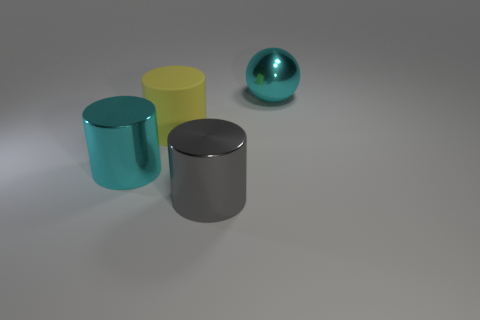Add 3 big gray objects. How many objects exist? 7 Subtract all cylinders. How many objects are left? 1 Subtract all big cubes. Subtract all large cylinders. How many objects are left? 1 Add 4 gray metallic things. How many gray metallic things are left? 5 Add 2 big rubber cylinders. How many big rubber cylinders exist? 3 Subtract 1 cyan cylinders. How many objects are left? 3 